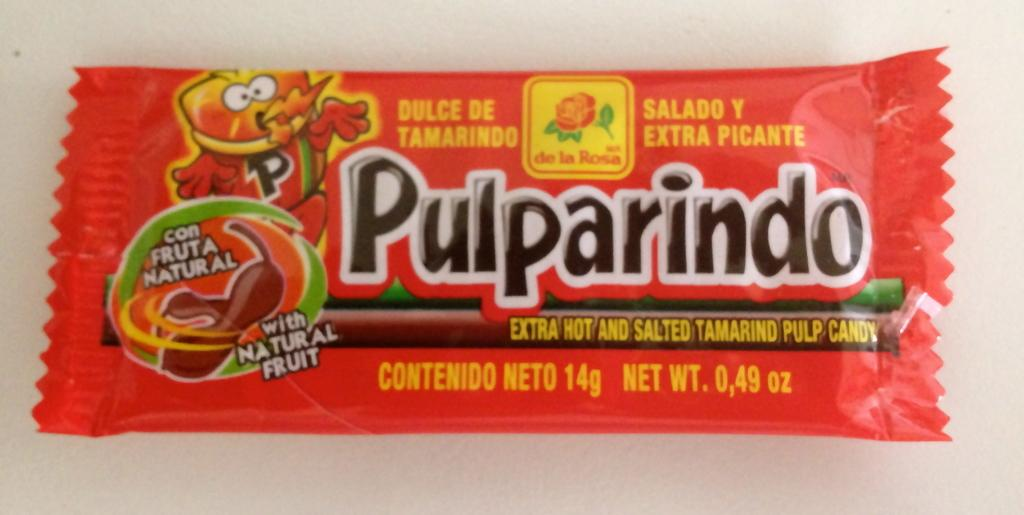Provide a one-sentence caption for the provided image. The red package of candy is called Pulparindo. 